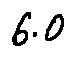<formula> <loc_0><loc_0><loc_500><loc_500>6 . 0</formula> 